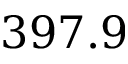<formula> <loc_0><loc_0><loc_500><loc_500>3 9 7 . 9</formula> 